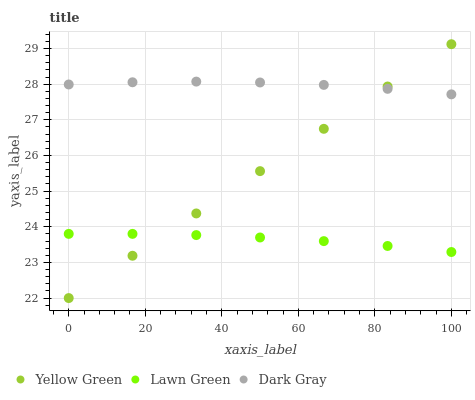Does Lawn Green have the minimum area under the curve?
Answer yes or no. Yes. Does Dark Gray have the maximum area under the curve?
Answer yes or no. Yes. Does Yellow Green have the minimum area under the curve?
Answer yes or no. No. Does Yellow Green have the maximum area under the curve?
Answer yes or no. No. Is Yellow Green the smoothest?
Answer yes or no. Yes. Is Dark Gray the roughest?
Answer yes or no. Yes. Is Lawn Green the smoothest?
Answer yes or no. No. Is Lawn Green the roughest?
Answer yes or no. No. Does Yellow Green have the lowest value?
Answer yes or no. Yes. Does Lawn Green have the lowest value?
Answer yes or no. No. Does Yellow Green have the highest value?
Answer yes or no. Yes. Does Lawn Green have the highest value?
Answer yes or no. No. Is Lawn Green less than Dark Gray?
Answer yes or no. Yes. Is Dark Gray greater than Lawn Green?
Answer yes or no. Yes. Does Yellow Green intersect Dark Gray?
Answer yes or no. Yes. Is Yellow Green less than Dark Gray?
Answer yes or no. No. Is Yellow Green greater than Dark Gray?
Answer yes or no. No. Does Lawn Green intersect Dark Gray?
Answer yes or no. No. 